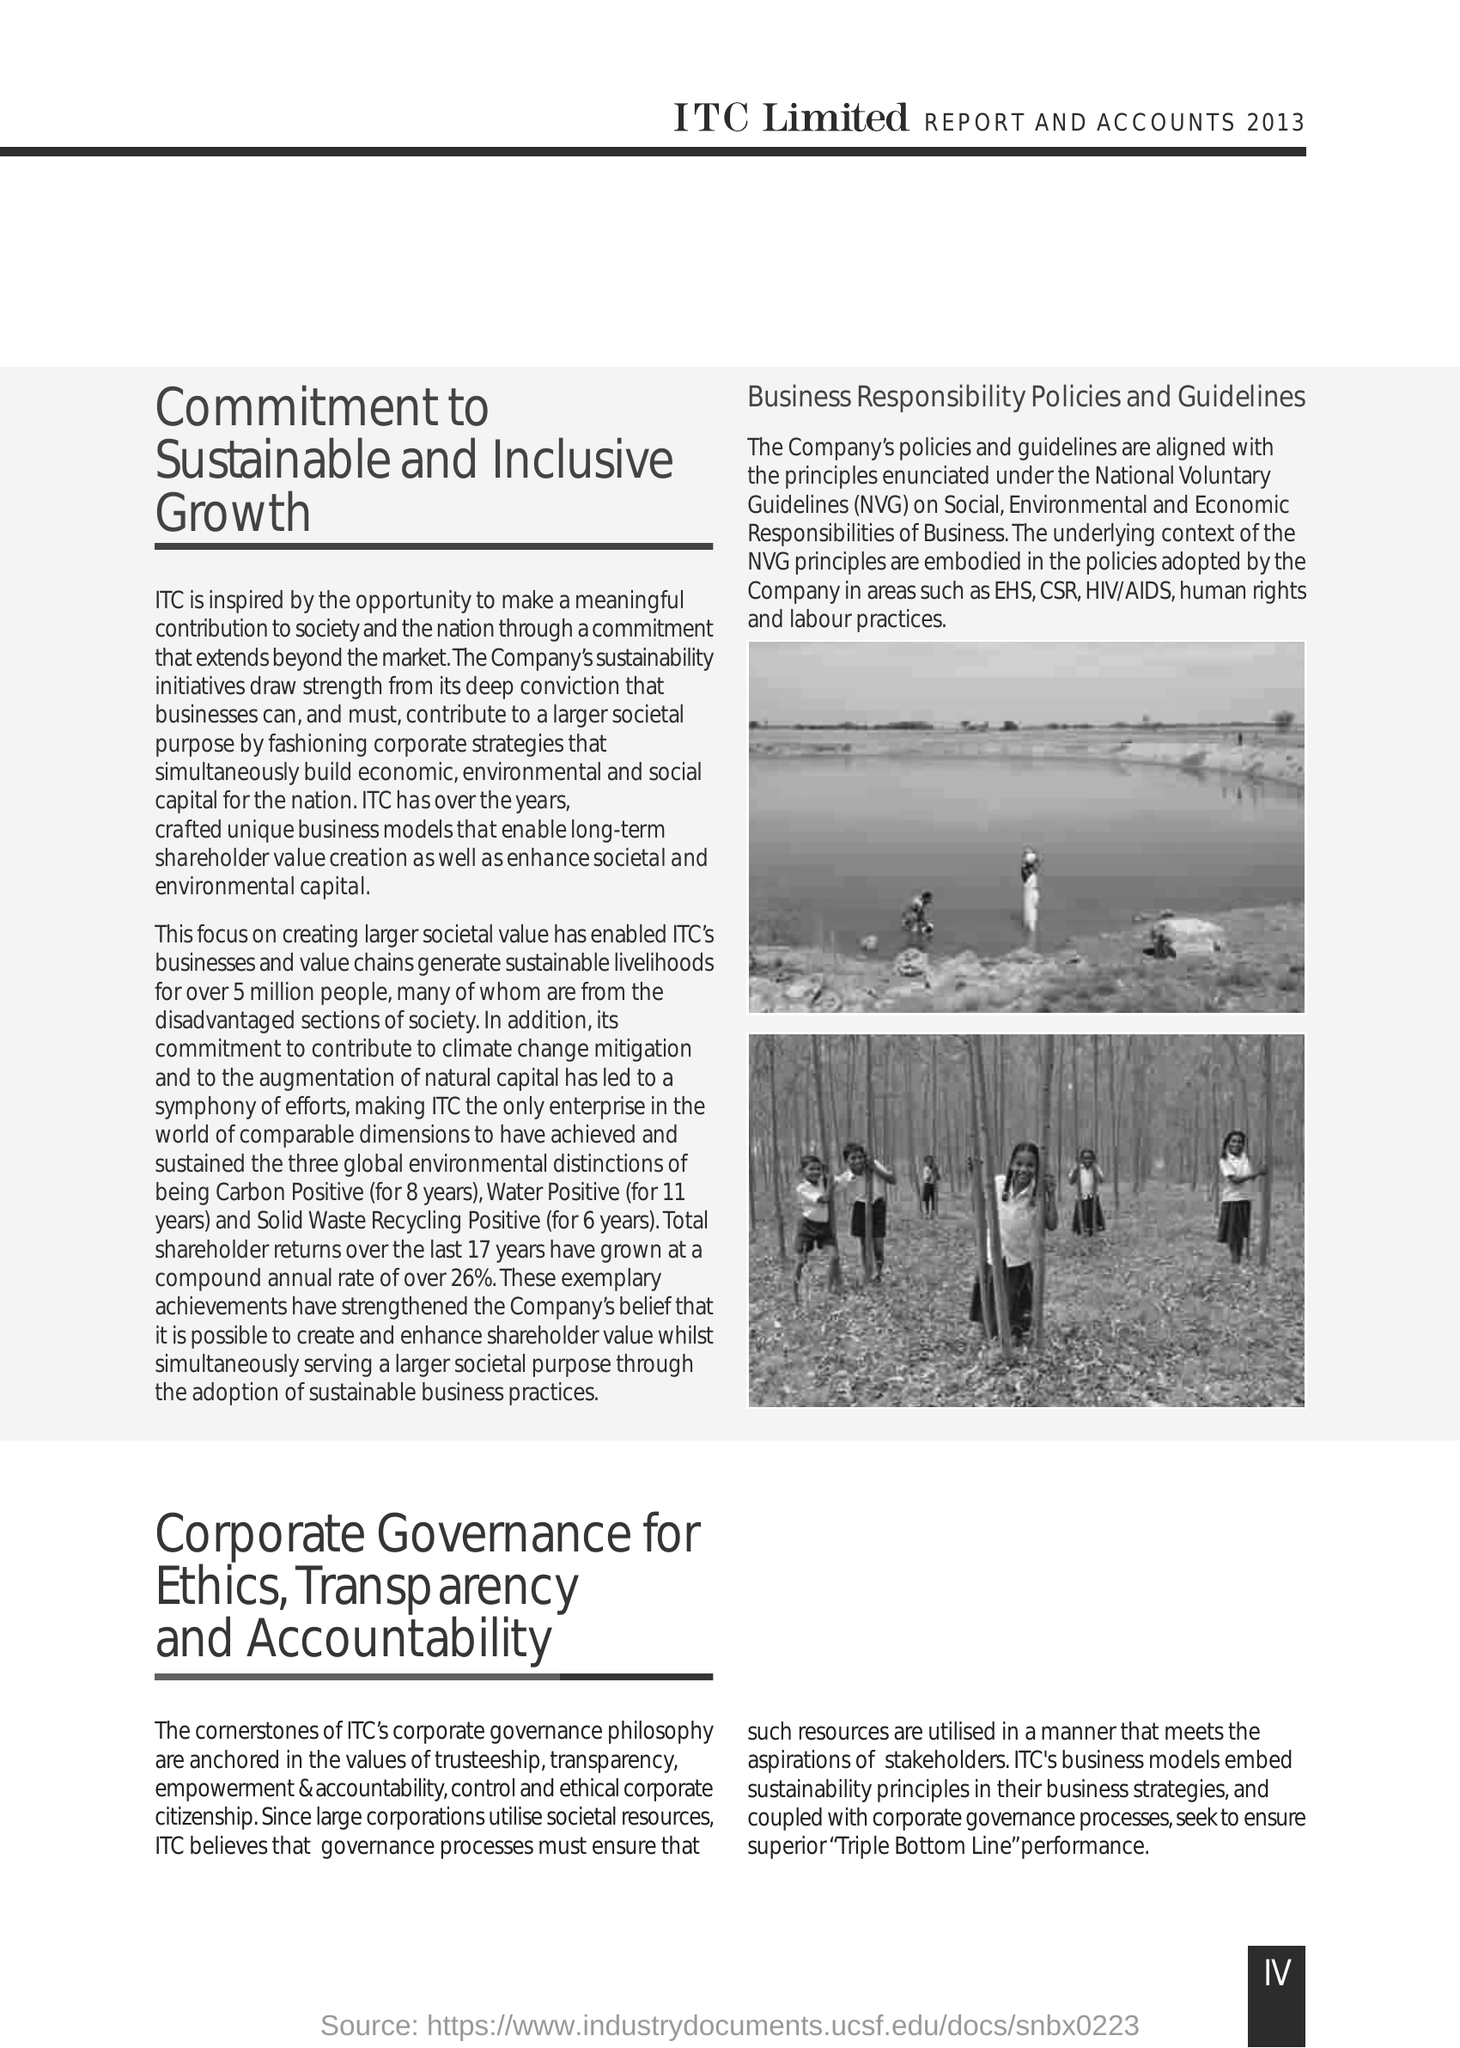Highlight a few significant elements in this photo. The fullform of NVG is "National Voluntary Guidelines". 